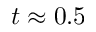Convert formula to latex. <formula><loc_0><loc_0><loc_500><loc_500>t \approx 0 . 5</formula> 